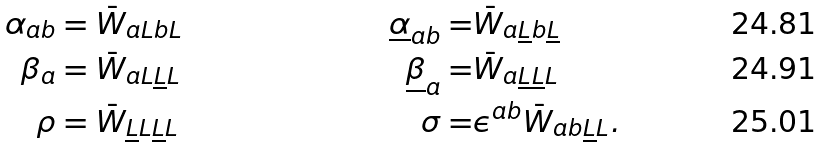<formula> <loc_0><loc_0><loc_500><loc_500>{ \alpha } _ { a b } & = \bar { W } _ { a L b L } \ & \underline { \alpha } _ { a b } = & \bar { W } _ { a \underline { L } b \underline { L } } \\ \beta _ { a } & = \bar { W } _ { a L \underline { L } L } \ & \underline { \beta } _ { a } = & \bar { W } _ { a \underline { L } \underline { L } L } \\ \rho & = \bar { W } _ { \underline { L } L \underline { L } L } \ & \sigma = & \epsilon ^ { a b } \bar { W } _ { a b \underline { L } L } .</formula> 